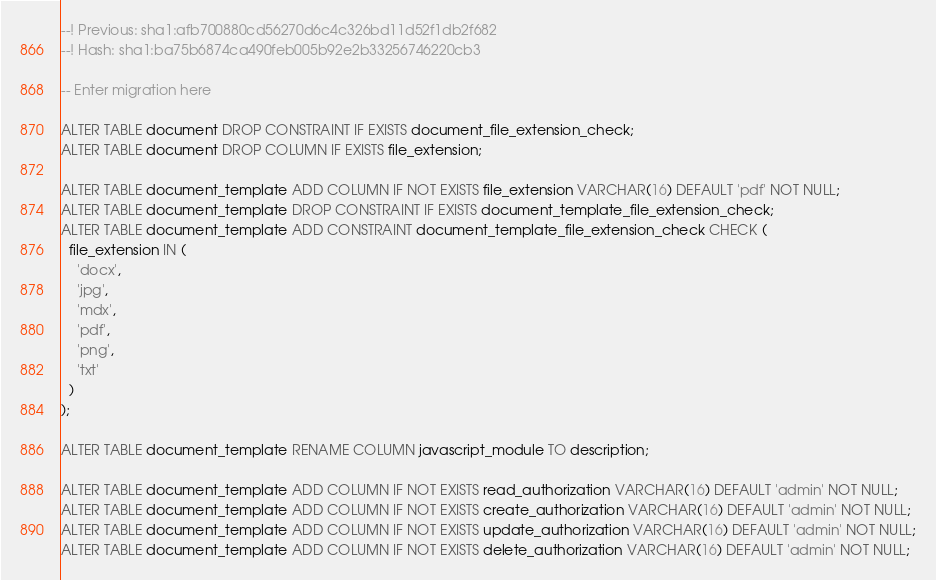<code> <loc_0><loc_0><loc_500><loc_500><_SQL_>--! Previous: sha1:afb700880cd56270d6c4c326bd11d52f1db2f682
--! Hash: sha1:ba75b6874ca490feb005b92e2b33256746220cb3

-- Enter migration here

ALTER TABLE document DROP CONSTRAINT IF EXISTS document_file_extension_check;
ALTER TABLE document DROP COLUMN IF EXISTS file_extension;

ALTER TABLE document_template ADD COLUMN IF NOT EXISTS file_extension VARCHAR(16) DEFAULT 'pdf' NOT NULL;
ALTER TABLE document_template DROP CONSTRAINT IF EXISTS document_template_file_extension_check;
ALTER TABLE document_template ADD CONSTRAINT document_template_file_extension_check CHECK (
  file_extension IN (
    'docx',
    'jpg',
    'mdx',
    'pdf',
    'png',
    'txt'
  )
);

ALTER TABLE document_template RENAME COLUMN javascript_module TO description;

ALTER TABLE document_template ADD COLUMN IF NOT EXISTS read_authorization VARCHAR(16) DEFAULT 'admin' NOT NULL;
ALTER TABLE document_template ADD COLUMN IF NOT EXISTS create_authorization VARCHAR(16) DEFAULT 'admin' NOT NULL;
ALTER TABLE document_template ADD COLUMN IF NOT EXISTS update_authorization VARCHAR(16) DEFAULT 'admin' NOT NULL;
ALTER TABLE document_template ADD COLUMN IF NOT EXISTS delete_authorization VARCHAR(16) DEFAULT 'admin' NOT NULL;
</code> 